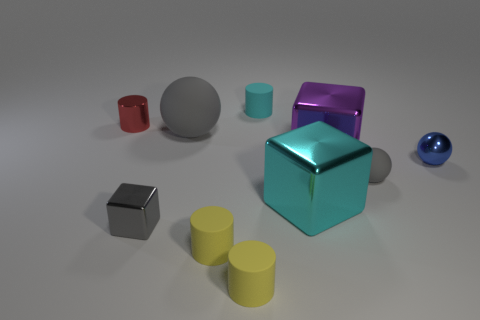Do the large rubber object and the small rubber sphere have the same color? Yes, both the large rubber object, which appears to be a cube, and the small rubber sphere exhibit a similar shade of blue. Their colors are quite close, contributing to a harmonious arrangement within the image composed of various geometric shapes and colors. 